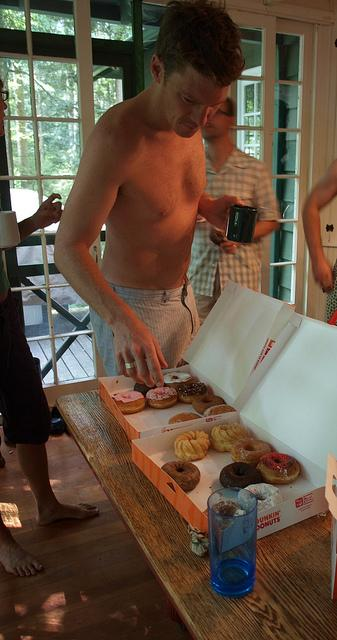What is the donut called that has ridges down the sides?

Choices:
A) apple fritter
B) eclair
C) long john
D) cruller cruller 